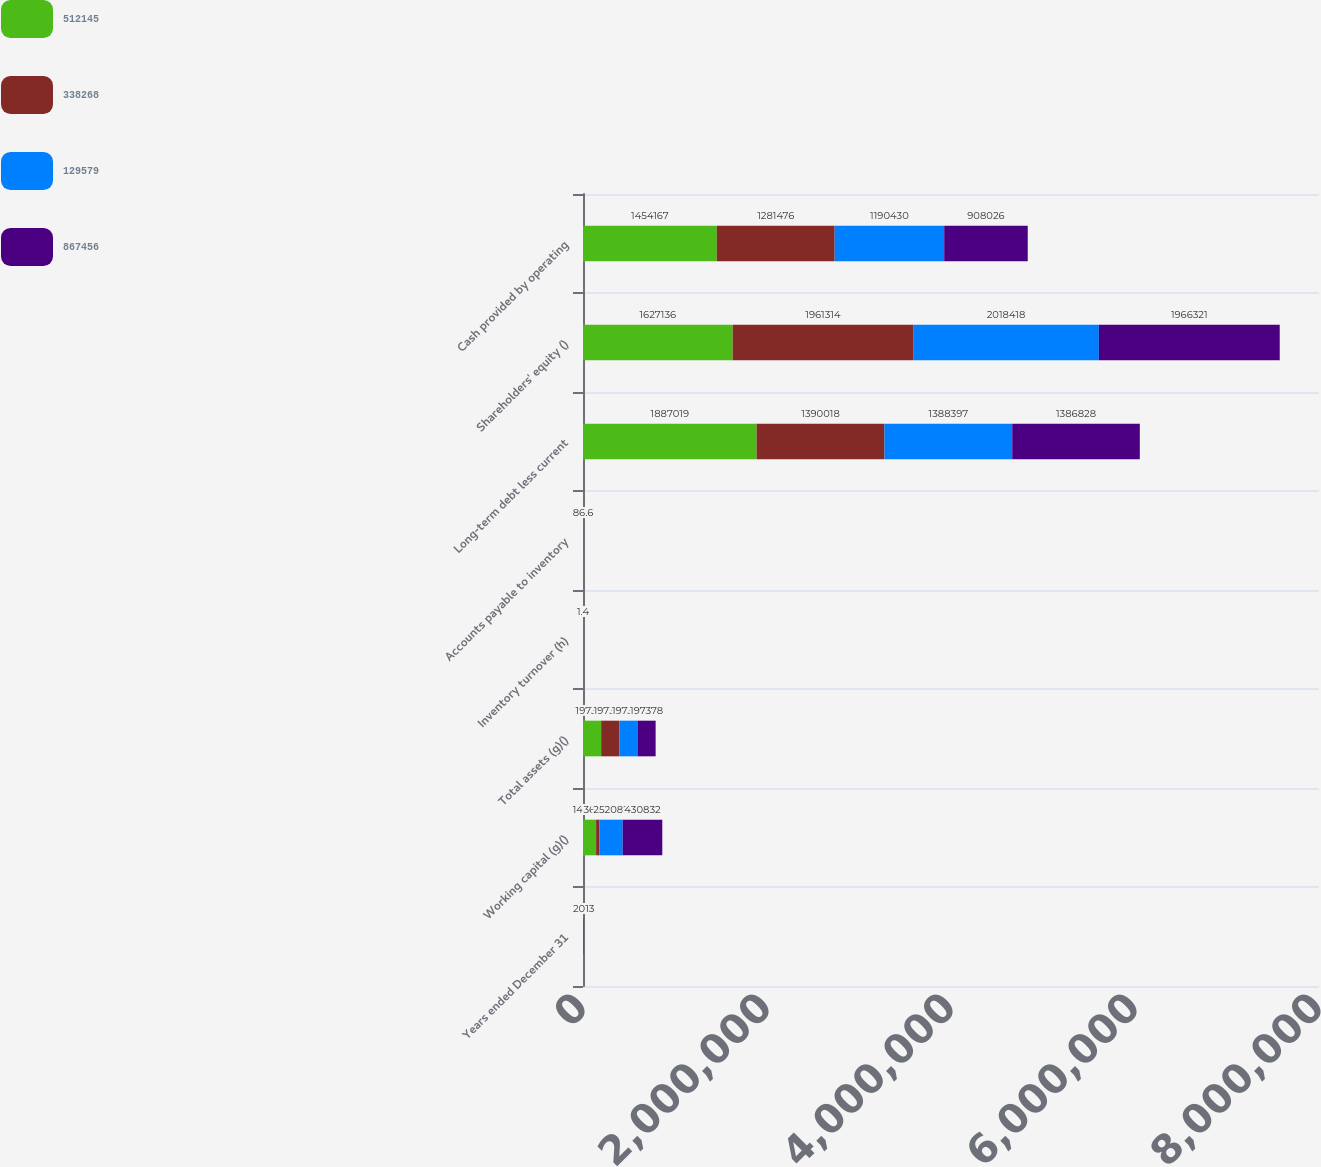<chart> <loc_0><loc_0><loc_500><loc_500><stacked_bar_chart><ecel><fcel>Years ended December 31<fcel>Working capital (g)()<fcel>Total assets (g)()<fcel>Inventory turnover (h)<fcel>Accounts payable to inventory<fcel>Long-term debt less current<fcel>Shareholders' equity ()<fcel>Cash provided by operating<nl><fcel>512145<fcel>2016<fcel>142674<fcel>197378<fcel>1.5<fcel>105.7<fcel>1.88702e+06<fcel>1.62714e+06<fcel>1.45417e+06<nl><fcel>338268<fcel>2015<fcel>36372<fcel>197378<fcel>1.5<fcel>99.1<fcel>1.39002e+06<fcel>1.96131e+06<fcel>1.28148e+06<nl><fcel>129579<fcel>2014<fcel>252082<fcel>197378<fcel>1.4<fcel>94.6<fcel>1.3884e+06<fcel>2.01842e+06<fcel>1.19043e+06<nl><fcel>867456<fcel>2013<fcel>430832<fcel>197378<fcel>1.4<fcel>86.6<fcel>1.38683e+06<fcel>1.96632e+06<fcel>908026<nl></chart> 